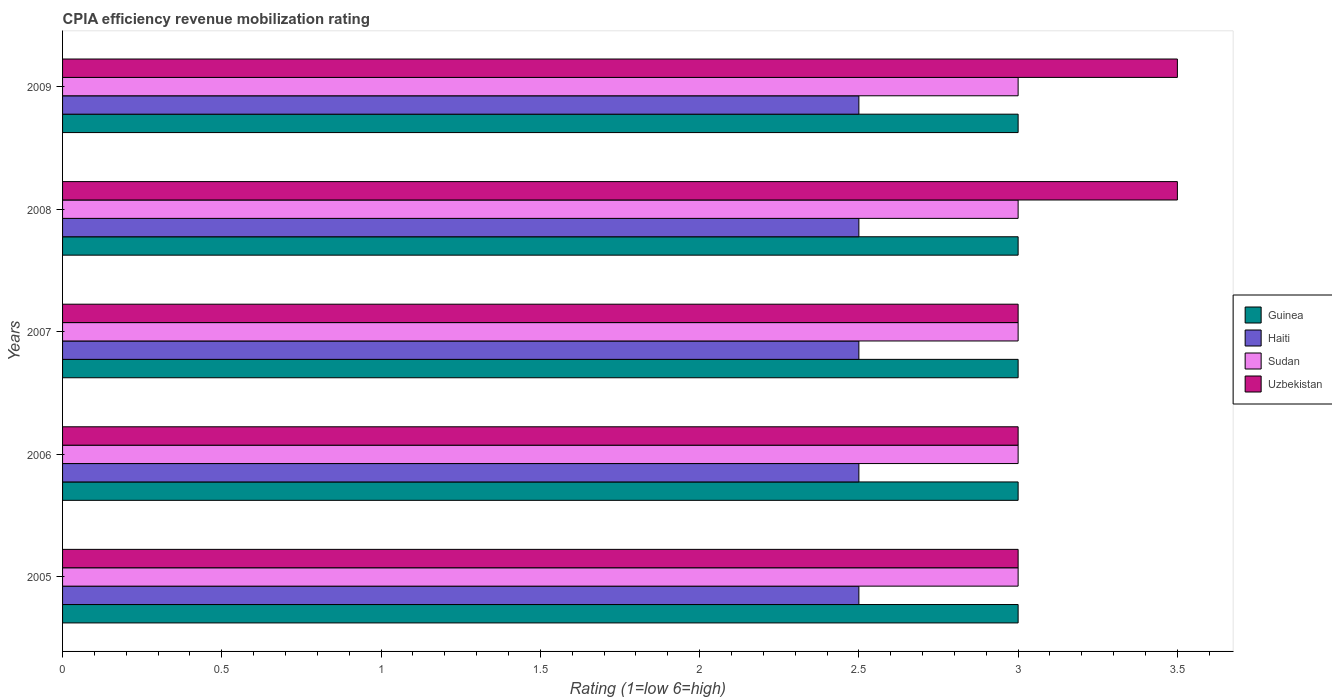How many groups of bars are there?
Your answer should be compact. 5. How many bars are there on the 3rd tick from the top?
Your response must be concise. 4. What is the CPIA rating in Haiti in 2006?
Provide a succinct answer. 2.5. Across all years, what is the minimum CPIA rating in Haiti?
Your response must be concise. 2.5. In which year was the CPIA rating in Uzbekistan minimum?
Keep it short and to the point. 2005. What is the difference between the CPIA rating in Uzbekistan in 2007 and that in 2009?
Give a very brief answer. -0.5. What is the difference between the CPIA rating in Guinea in 2009 and the CPIA rating in Haiti in 2007?
Offer a terse response. 0.5. What is the average CPIA rating in Haiti per year?
Keep it short and to the point. 2.5. Is the difference between the CPIA rating in Haiti in 2005 and 2006 greater than the difference between the CPIA rating in Sudan in 2005 and 2006?
Provide a succinct answer. No. What is the difference between the highest and the second highest CPIA rating in Sudan?
Provide a short and direct response. 0. What is the difference between the highest and the lowest CPIA rating in Uzbekistan?
Offer a terse response. 0.5. In how many years, is the CPIA rating in Guinea greater than the average CPIA rating in Guinea taken over all years?
Provide a short and direct response. 0. Is the sum of the CPIA rating in Haiti in 2005 and 2006 greater than the maximum CPIA rating in Uzbekistan across all years?
Ensure brevity in your answer.  Yes. What does the 1st bar from the top in 2005 represents?
Your answer should be very brief. Uzbekistan. What does the 3rd bar from the bottom in 2006 represents?
Make the answer very short. Sudan. Are all the bars in the graph horizontal?
Provide a short and direct response. Yes. Are the values on the major ticks of X-axis written in scientific E-notation?
Ensure brevity in your answer.  No. Does the graph contain any zero values?
Your response must be concise. No. Where does the legend appear in the graph?
Your response must be concise. Center right. How many legend labels are there?
Offer a very short reply. 4. What is the title of the graph?
Offer a very short reply. CPIA efficiency revenue mobilization rating. What is the label or title of the X-axis?
Give a very brief answer. Rating (1=low 6=high). What is the label or title of the Y-axis?
Offer a very short reply. Years. What is the Rating (1=low 6=high) of Guinea in 2005?
Keep it short and to the point. 3. What is the Rating (1=low 6=high) in Sudan in 2005?
Your answer should be very brief. 3. What is the Rating (1=low 6=high) in Uzbekistan in 2005?
Ensure brevity in your answer.  3. What is the Rating (1=low 6=high) in Haiti in 2006?
Provide a succinct answer. 2.5. What is the Rating (1=low 6=high) of Sudan in 2006?
Provide a short and direct response. 3. What is the Rating (1=low 6=high) of Uzbekistan in 2006?
Your response must be concise. 3. What is the Rating (1=low 6=high) of Haiti in 2007?
Your answer should be very brief. 2.5. What is the Rating (1=low 6=high) in Guinea in 2008?
Make the answer very short. 3. What is the Rating (1=low 6=high) of Haiti in 2008?
Your answer should be compact. 2.5. What is the Rating (1=low 6=high) in Uzbekistan in 2009?
Offer a very short reply. 3.5. Across all years, what is the maximum Rating (1=low 6=high) of Haiti?
Provide a short and direct response. 2.5. Across all years, what is the minimum Rating (1=low 6=high) of Guinea?
Your response must be concise. 3. Across all years, what is the minimum Rating (1=low 6=high) of Sudan?
Provide a succinct answer. 3. What is the total Rating (1=low 6=high) in Haiti in the graph?
Your answer should be compact. 12.5. What is the difference between the Rating (1=low 6=high) of Guinea in 2005 and that in 2006?
Keep it short and to the point. 0. What is the difference between the Rating (1=low 6=high) of Haiti in 2005 and that in 2006?
Your response must be concise. 0. What is the difference between the Rating (1=low 6=high) of Uzbekistan in 2005 and that in 2006?
Give a very brief answer. 0. What is the difference between the Rating (1=low 6=high) in Guinea in 2005 and that in 2007?
Your answer should be compact. 0. What is the difference between the Rating (1=low 6=high) of Guinea in 2005 and that in 2008?
Give a very brief answer. 0. What is the difference between the Rating (1=low 6=high) in Sudan in 2005 and that in 2008?
Provide a succinct answer. 0. What is the difference between the Rating (1=low 6=high) of Sudan in 2005 and that in 2009?
Your response must be concise. 0. What is the difference between the Rating (1=low 6=high) of Haiti in 2006 and that in 2007?
Make the answer very short. 0. What is the difference between the Rating (1=low 6=high) in Uzbekistan in 2006 and that in 2007?
Your answer should be very brief. 0. What is the difference between the Rating (1=low 6=high) in Guinea in 2006 and that in 2008?
Give a very brief answer. 0. What is the difference between the Rating (1=low 6=high) of Haiti in 2006 and that in 2008?
Provide a succinct answer. 0. What is the difference between the Rating (1=low 6=high) of Sudan in 2006 and that in 2008?
Your answer should be compact. 0. What is the difference between the Rating (1=low 6=high) of Guinea in 2006 and that in 2009?
Keep it short and to the point. 0. What is the difference between the Rating (1=low 6=high) in Uzbekistan in 2006 and that in 2009?
Offer a very short reply. -0.5. What is the difference between the Rating (1=low 6=high) of Guinea in 2007 and that in 2008?
Your answer should be compact. 0. What is the difference between the Rating (1=low 6=high) of Sudan in 2007 and that in 2008?
Keep it short and to the point. 0. What is the difference between the Rating (1=low 6=high) in Uzbekistan in 2007 and that in 2008?
Provide a succinct answer. -0.5. What is the difference between the Rating (1=low 6=high) in Sudan in 2007 and that in 2009?
Provide a short and direct response. 0. What is the difference between the Rating (1=low 6=high) of Guinea in 2008 and that in 2009?
Keep it short and to the point. 0. What is the difference between the Rating (1=low 6=high) in Guinea in 2005 and the Rating (1=low 6=high) in Haiti in 2006?
Make the answer very short. 0.5. What is the difference between the Rating (1=low 6=high) in Guinea in 2005 and the Rating (1=low 6=high) in Sudan in 2006?
Your answer should be very brief. 0. What is the difference between the Rating (1=low 6=high) of Sudan in 2005 and the Rating (1=low 6=high) of Uzbekistan in 2006?
Offer a very short reply. 0. What is the difference between the Rating (1=low 6=high) of Guinea in 2005 and the Rating (1=low 6=high) of Sudan in 2007?
Your answer should be compact. 0. What is the difference between the Rating (1=low 6=high) of Guinea in 2005 and the Rating (1=low 6=high) of Uzbekistan in 2007?
Keep it short and to the point. 0. What is the difference between the Rating (1=low 6=high) of Haiti in 2005 and the Rating (1=low 6=high) of Sudan in 2007?
Keep it short and to the point. -0.5. What is the difference between the Rating (1=low 6=high) of Guinea in 2005 and the Rating (1=low 6=high) of Sudan in 2008?
Make the answer very short. 0. What is the difference between the Rating (1=low 6=high) of Guinea in 2005 and the Rating (1=low 6=high) of Uzbekistan in 2008?
Provide a succinct answer. -0.5. What is the difference between the Rating (1=low 6=high) of Haiti in 2005 and the Rating (1=low 6=high) of Sudan in 2008?
Provide a short and direct response. -0.5. What is the difference between the Rating (1=low 6=high) of Haiti in 2005 and the Rating (1=low 6=high) of Uzbekistan in 2008?
Your answer should be compact. -1. What is the difference between the Rating (1=low 6=high) of Sudan in 2005 and the Rating (1=low 6=high) of Uzbekistan in 2008?
Provide a succinct answer. -0.5. What is the difference between the Rating (1=low 6=high) in Guinea in 2005 and the Rating (1=low 6=high) in Haiti in 2009?
Keep it short and to the point. 0.5. What is the difference between the Rating (1=low 6=high) in Guinea in 2005 and the Rating (1=low 6=high) in Sudan in 2009?
Your answer should be very brief. 0. What is the difference between the Rating (1=low 6=high) of Guinea in 2005 and the Rating (1=low 6=high) of Uzbekistan in 2009?
Your answer should be very brief. -0.5. What is the difference between the Rating (1=low 6=high) of Haiti in 2005 and the Rating (1=low 6=high) of Sudan in 2009?
Give a very brief answer. -0.5. What is the difference between the Rating (1=low 6=high) of Sudan in 2005 and the Rating (1=low 6=high) of Uzbekistan in 2009?
Ensure brevity in your answer.  -0.5. What is the difference between the Rating (1=low 6=high) in Guinea in 2006 and the Rating (1=low 6=high) in Sudan in 2007?
Make the answer very short. 0. What is the difference between the Rating (1=low 6=high) in Sudan in 2006 and the Rating (1=low 6=high) in Uzbekistan in 2007?
Provide a succinct answer. 0. What is the difference between the Rating (1=low 6=high) in Guinea in 2006 and the Rating (1=low 6=high) in Sudan in 2008?
Offer a very short reply. 0. What is the difference between the Rating (1=low 6=high) in Haiti in 2006 and the Rating (1=low 6=high) in Uzbekistan in 2008?
Your answer should be very brief. -1. What is the difference between the Rating (1=low 6=high) in Sudan in 2006 and the Rating (1=low 6=high) in Uzbekistan in 2008?
Provide a short and direct response. -0.5. What is the difference between the Rating (1=low 6=high) of Guinea in 2006 and the Rating (1=low 6=high) of Sudan in 2009?
Ensure brevity in your answer.  0. What is the difference between the Rating (1=low 6=high) in Guinea in 2006 and the Rating (1=low 6=high) in Uzbekistan in 2009?
Offer a terse response. -0.5. What is the difference between the Rating (1=low 6=high) in Haiti in 2006 and the Rating (1=low 6=high) in Sudan in 2009?
Your response must be concise. -0.5. What is the difference between the Rating (1=low 6=high) in Haiti in 2006 and the Rating (1=low 6=high) in Uzbekistan in 2009?
Provide a short and direct response. -1. What is the difference between the Rating (1=low 6=high) in Sudan in 2006 and the Rating (1=low 6=high) in Uzbekistan in 2009?
Provide a succinct answer. -0.5. What is the difference between the Rating (1=low 6=high) of Guinea in 2007 and the Rating (1=low 6=high) of Haiti in 2008?
Provide a succinct answer. 0.5. What is the difference between the Rating (1=low 6=high) of Guinea in 2007 and the Rating (1=low 6=high) of Uzbekistan in 2009?
Give a very brief answer. -0.5. What is the difference between the Rating (1=low 6=high) in Haiti in 2007 and the Rating (1=low 6=high) in Uzbekistan in 2009?
Give a very brief answer. -1. What is the difference between the Rating (1=low 6=high) in Haiti in 2008 and the Rating (1=low 6=high) in Sudan in 2009?
Provide a succinct answer. -0.5. What is the average Rating (1=low 6=high) in Uzbekistan per year?
Provide a succinct answer. 3.2. In the year 2005, what is the difference between the Rating (1=low 6=high) in Guinea and Rating (1=low 6=high) in Sudan?
Ensure brevity in your answer.  0. In the year 2005, what is the difference between the Rating (1=low 6=high) of Haiti and Rating (1=low 6=high) of Sudan?
Give a very brief answer. -0.5. In the year 2005, what is the difference between the Rating (1=low 6=high) in Sudan and Rating (1=low 6=high) in Uzbekistan?
Your response must be concise. 0. In the year 2006, what is the difference between the Rating (1=low 6=high) in Guinea and Rating (1=low 6=high) in Haiti?
Keep it short and to the point. 0.5. In the year 2006, what is the difference between the Rating (1=low 6=high) of Guinea and Rating (1=low 6=high) of Sudan?
Offer a very short reply. 0. In the year 2006, what is the difference between the Rating (1=low 6=high) in Haiti and Rating (1=low 6=high) in Sudan?
Offer a terse response. -0.5. In the year 2006, what is the difference between the Rating (1=low 6=high) of Haiti and Rating (1=low 6=high) of Uzbekistan?
Keep it short and to the point. -0.5. In the year 2007, what is the difference between the Rating (1=low 6=high) of Haiti and Rating (1=low 6=high) of Uzbekistan?
Your answer should be very brief. -0.5. In the year 2007, what is the difference between the Rating (1=low 6=high) of Sudan and Rating (1=low 6=high) of Uzbekistan?
Your answer should be very brief. 0. In the year 2008, what is the difference between the Rating (1=low 6=high) of Guinea and Rating (1=low 6=high) of Uzbekistan?
Offer a terse response. -0.5. In the year 2008, what is the difference between the Rating (1=low 6=high) in Sudan and Rating (1=low 6=high) in Uzbekistan?
Ensure brevity in your answer.  -0.5. In the year 2009, what is the difference between the Rating (1=low 6=high) of Haiti and Rating (1=low 6=high) of Sudan?
Your answer should be very brief. -0.5. In the year 2009, what is the difference between the Rating (1=low 6=high) of Haiti and Rating (1=low 6=high) of Uzbekistan?
Make the answer very short. -1. In the year 2009, what is the difference between the Rating (1=low 6=high) of Sudan and Rating (1=low 6=high) of Uzbekistan?
Your response must be concise. -0.5. What is the ratio of the Rating (1=low 6=high) of Haiti in 2005 to that in 2006?
Your answer should be very brief. 1. What is the ratio of the Rating (1=low 6=high) in Sudan in 2005 to that in 2006?
Ensure brevity in your answer.  1. What is the ratio of the Rating (1=low 6=high) in Uzbekistan in 2005 to that in 2006?
Keep it short and to the point. 1. What is the ratio of the Rating (1=low 6=high) in Guinea in 2005 to that in 2007?
Offer a terse response. 1. What is the ratio of the Rating (1=low 6=high) of Haiti in 2005 to that in 2007?
Your response must be concise. 1. What is the ratio of the Rating (1=low 6=high) in Uzbekistan in 2005 to that in 2007?
Keep it short and to the point. 1. What is the ratio of the Rating (1=low 6=high) of Haiti in 2005 to that in 2008?
Your response must be concise. 1. What is the ratio of the Rating (1=low 6=high) in Sudan in 2005 to that in 2008?
Your response must be concise. 1. What is the ratio of the Rating (1=low 6=high) in Uzbekistan in 2005 to that in 2008?
Offer a very short reply. 0.86. What is the ratio of the Rating (1=low 6=high) in Haiti in 2005 to that in 2009?
Make the answer very short. 1. What is the ratio of the Rating (1=low 6=high) of Sudan in 2006 to that in 2007?
Offer a very short reply. 1. What is the ratio of the Rating (1=low 6=high) of Guinea in 2006 to that in 2008?
Offer a very short reply. 1. What is the ratio of the Rating (1=low 6=high) in Haiti in 2006 to that in 2008?
Make the answer very short. 1. What is the ratio of the Rating (1=low 6=high) in Uzbekistan in 2006 to that in 2008?
Provide a succinct answer. 0.86. What is the ratio of the Rating (1=low 6=high) of Haiti in 2007 to that in 2008?
Offer a terse response. 1. What is the ratio of the Rating (1=low 6=high) of Guinea in 2007 to that in 2009?
Make the answer very short. 1. What is the ratio of the Rating (1=low 6=high) in Uzbekistan in 2007 to that in 2009?
Provide a succinct answer. 0.86. What is the ratio of the Rating (1=low 6=high) of Guinea in 2008 to that in 2009?
Your answer should be compact. 1. What is the ratio of the Rating (1=low 6=high) in Sudan in 2008 to that in 2009?
Provide a succinct answer. 1. What is the ratio of the Rating (1=low 6=high) in Uzbekistan in 2008 to that in 2009?
Make the answer very short. 1. What is the difference between the highest and the second highest Rating (1=low 6=high) of Sudan?
Your response must be concise. 0. What is the difference between the highest and the lowest Rating (1=low 6=high) of Guinea?
Your response must be concise. 0. 